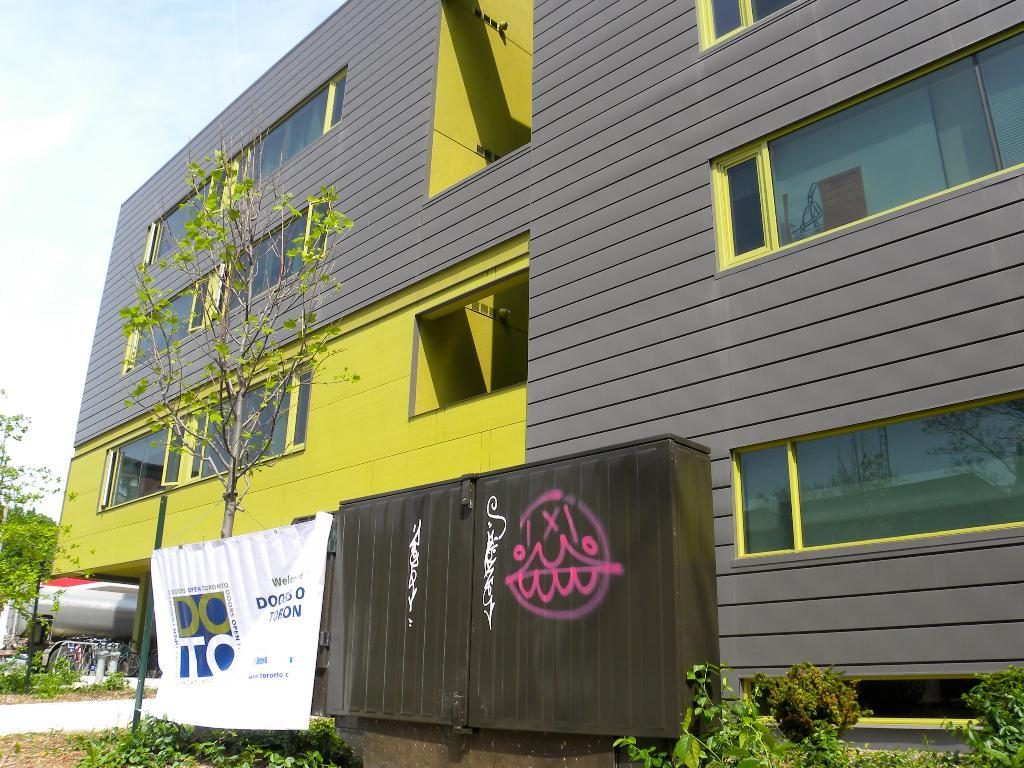What type of structure is visible in the image? There is a building in the image. What natural elements can be seen in the image? There are trees and plants in the image. What additional man-made object is present in the image? There is a metal box in the image. What message or information is conveyed by the banner in the image? The banner in the image has text, but we cannot determine the specific message without more information. What is the weather like in the image? The sky is cloudy in the image. What type of joke is being told by the finger in the image? There is no finger or joke present in the image. What type of arch can be seen in the image? There is no arch present in the image. 